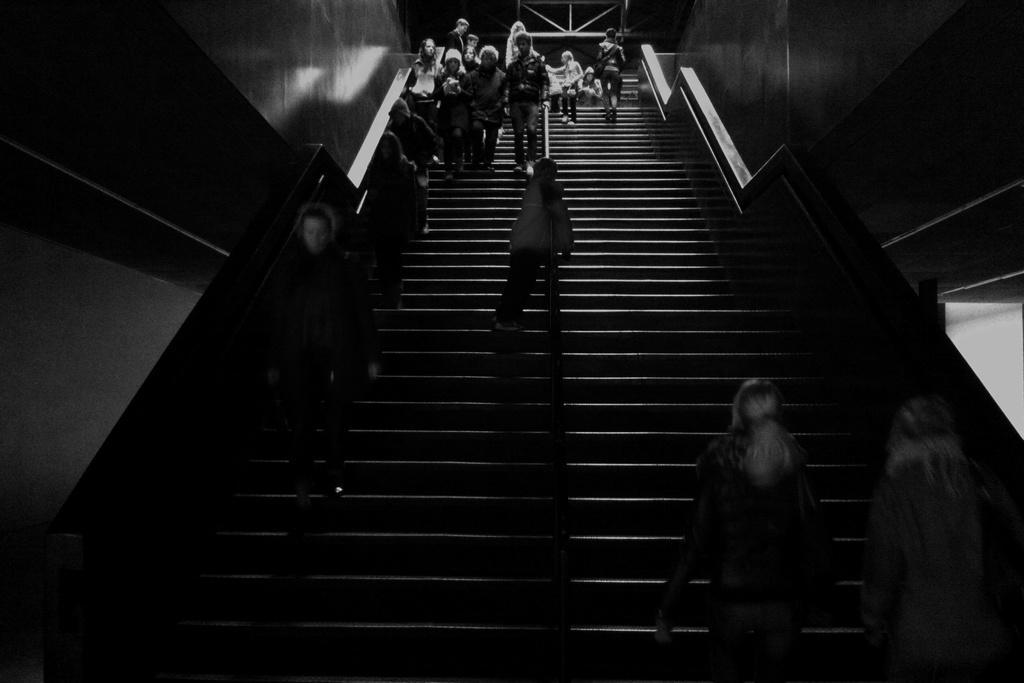How would you summarize this image in a sentence or two? This is an image clicked in the dark. Here I can see few people are walking on the states. On the right and left side of the image I can see the walls. 